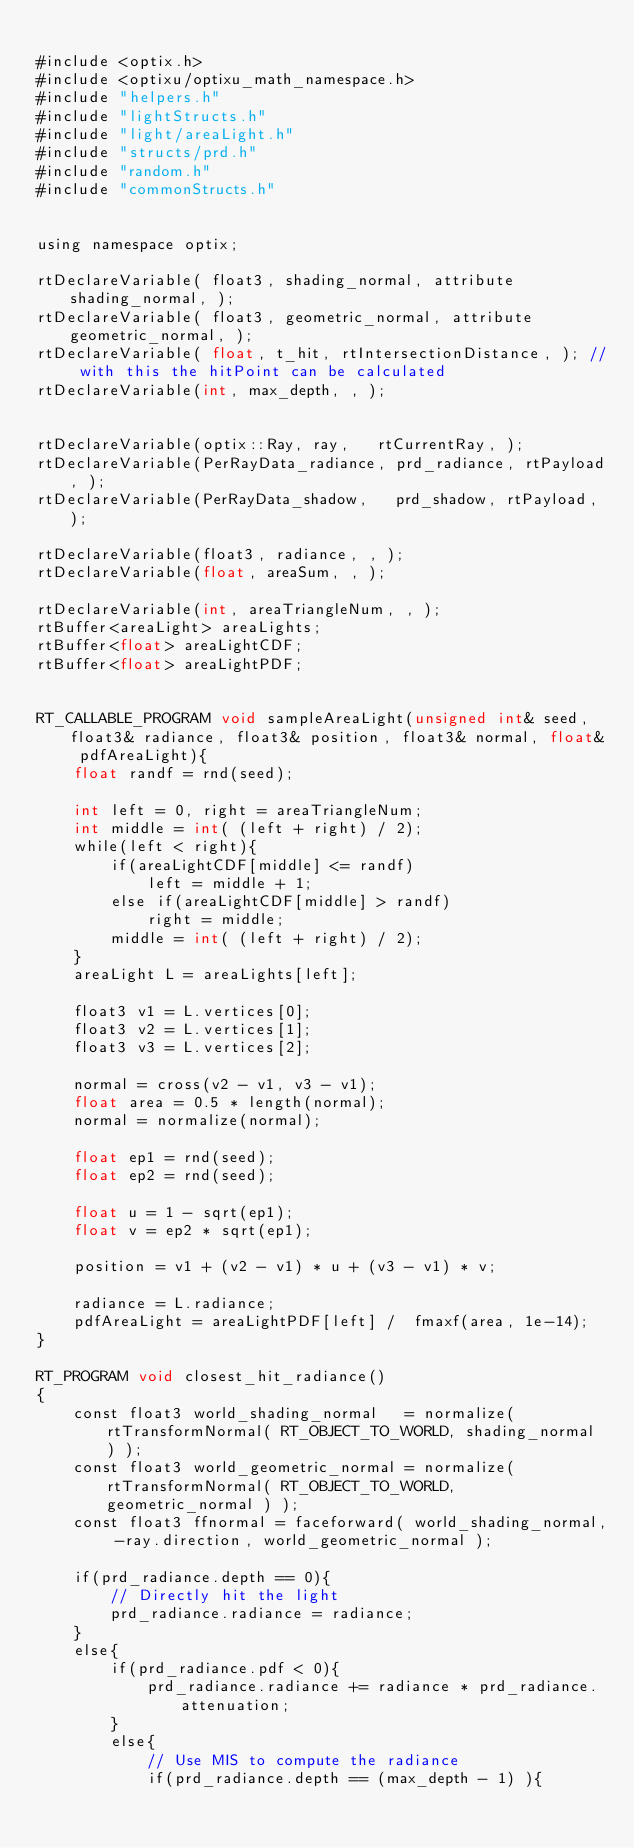Convert code to text. <code><loc_0><loc_0><loc_500><loc_500><_Cuda_>
#include <optix.h>
#include <optixu/optixu_math_namespace.h>
#include "helpers.h"
#include "lightStructs.h"
#include "light/areaLight.h"
#include "structs/prd.h"
#include "random.h"
#include "commonStructs.h"


using namespace optix;

rtDeclareVariable( float3, shading_normal, attribute shading_normal, ); 
rtDeclareVariable( float3, geometric_normal, attribute geometric_normal, );
rtDeclareVariable( float, t_hit, rtIntersectionDistance, ); // with this the hitPoint can be calculated
rtDeclareVariable(int, max_depth, , );


rtDeclareVariable(optix::Ray, ray,   rtCurrentRay, );
rtDeclareVariable(PerRayData_radiance, prd_radiance, rtPayload, );
rtDeclareVariable(PerRayData_shadow,   prd_shadow, rtPayload, );

rtDeclareVariable(float3, radiance, , );
rtDeclareVariable(float, areaSum, , );

rtDeclareVariable(int, areaTriangleNum, , );
rtBuffer<areaLight> areaLights;
rtBuffer<float> areaLightCDF;
rtBuffer<float> areaLightPDF;


RT_CALLABLE_PROGRAM void sampleAreaLight(unsigned int& seed, float3& radiance, float3& position, float3& normal, float& pdfAreaLight){
    float randf = rnd(seed);

    int left = 0, right = areaTriangleNum;
    int middle = int( (left + right) / 2);
    while(left < right){
        if(areaLightCDF[middle] <= randf)
            left = middle + 1;
        else if(areaLightCDF[middle] > randf)
            right = middle;
        middle = int( (left + right) / 2);
    }
    areaLight L = areaLights[left];
    
    float3 v1 = L.vertices[0];
    float3 v2 = L.vertices[1];
    float3 v3 = L.vertices[2];

    normal = cross(v2 - v1, v3 - v1);
    float area = 0.5 * length(normal);
    normal = normalize(normal);

    float ep1 = rnd(seed);
    float ep2 = rnd(seed);
    
    float u = 1 - sqrt(ep1);
    float v = ep2 * sqrt(ep1);

    position = v1 + (v2 - v1) * u + (v3 - v1) * v;

    radiance = L.radiance;
    pdfAreaLight = areaLightPDF[left] /  fmaxf(area, 1e-14);
}

RT_PROGRAM void closest_hit_radiance()
{
    const float3 world_shading_normal   = normalize( rtTransformNormal( RT_OBJECT_TO_WORLD, shading_normal ) );
    const float3 world_geometric_normal = normalize( rtTransformNormal( RT_OBJECT_TO_WORLD, geometric_normal ) );
    const float3 ffnormal = faceforward( world_shading_normal, -ray.direction, world_geometric_normal );

    if(prd_radiance.depth == 0){
        // Directly hit the light
        prd_radiance.radiance = radiance;
    }
    else{
        if(prd_radiance.pdf < 0){
            prd_radiance.radiance += radiance * prd_radiance.attenuation;
        }
        else{
            // Use MIS to compute the radiance
            if(prd_radiance.depth == (max_depth - 1) ){</code> 